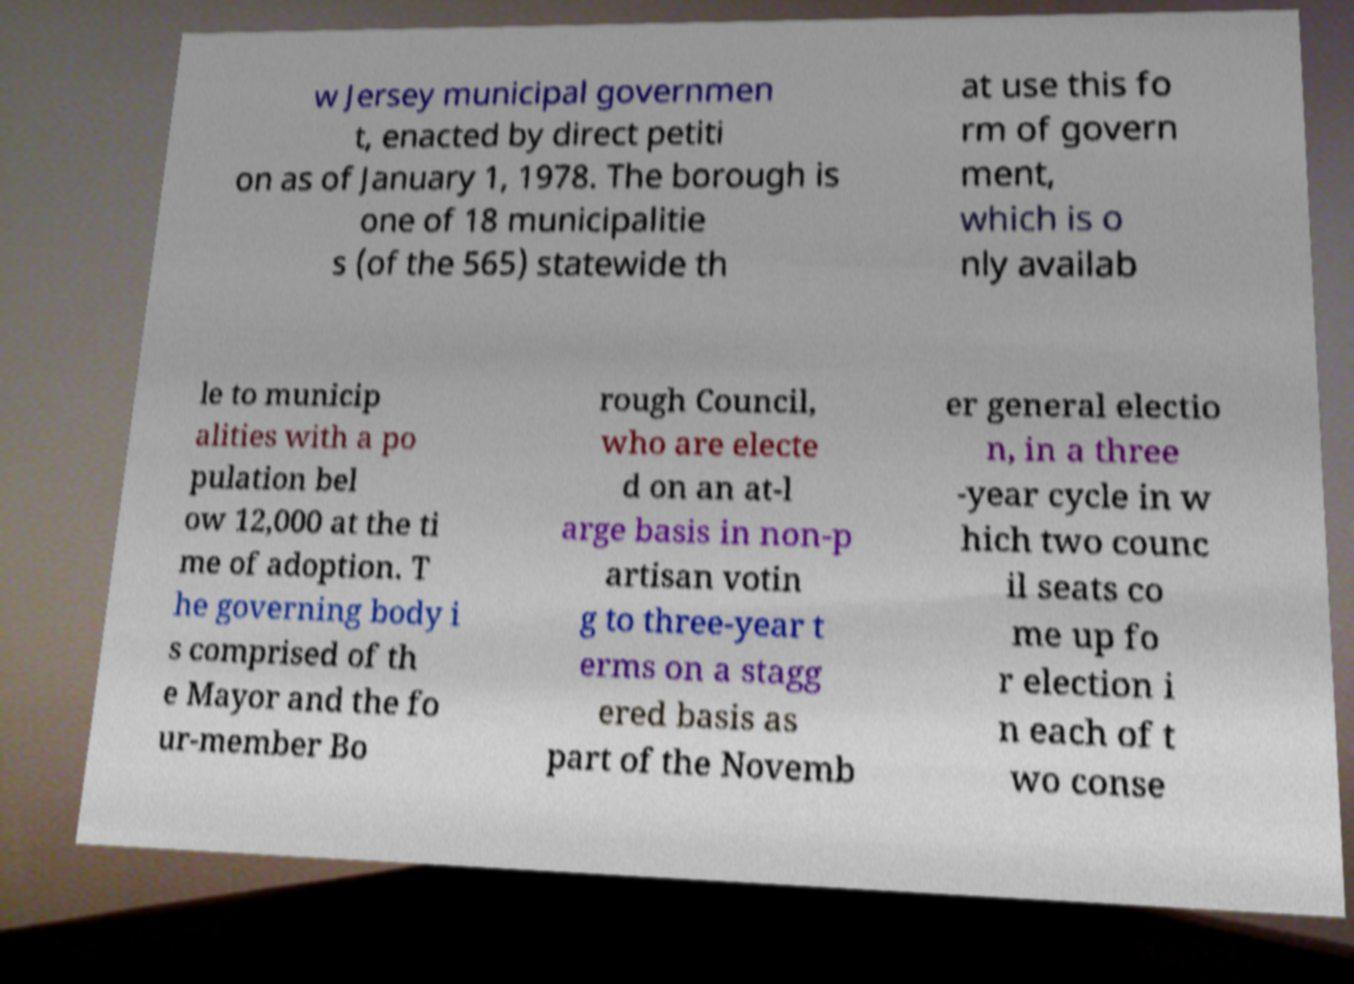For documentation purposes, I need the text within this image transcribed. Could you provide that? w Jersey municipal governmen t, enacted by direct petiti on as of January 1, 1978. The borough is one of 18 municipalitie s (of the 565) statewide th at use this fo rm of govern ment, which is o nly availab le to municip alities with a po pulation bel ow 12,000 at the ti me of adoption. T he governing body i s comprised of th e Mayor and the fo ur-member Bo rough Council, who are electe d on an at-l arge basis in non-p artisan votin g to three-year t erms on a stagg ered basis as part of the Novemb er general electio n, in a three -year cycle in w hich two counc il seats co me up fo r election i n each of t wo conse 